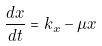<formula> <loc_0><loc_0><loc_500><loc_500>\frac { d x } { d t } = k _ { x } - \mu x</formula> 